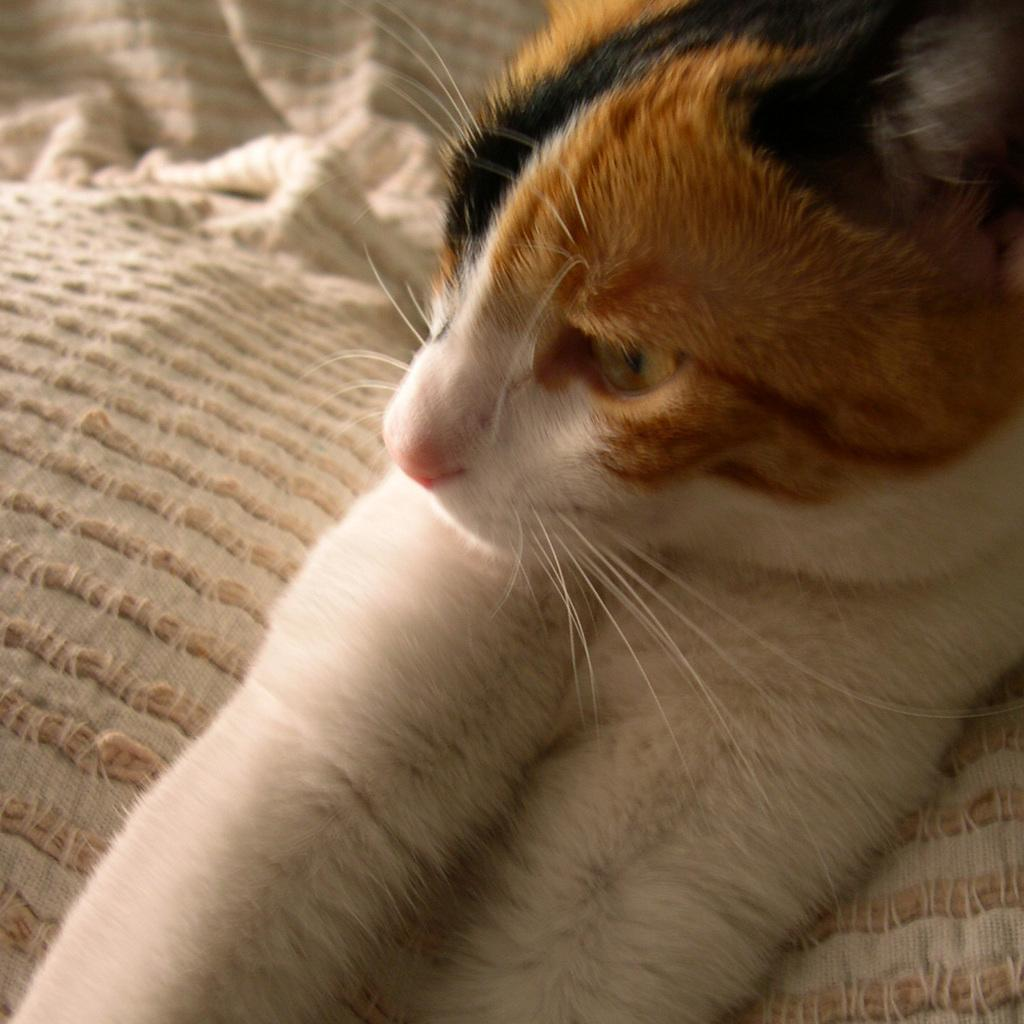What type of animal is in the image? There is a cat in the image. Where is the cat located? The cat is on a sofa. What type of ship can be seen in the background of the image? There is no ship present in the image; it only features a cat on a sofa. 